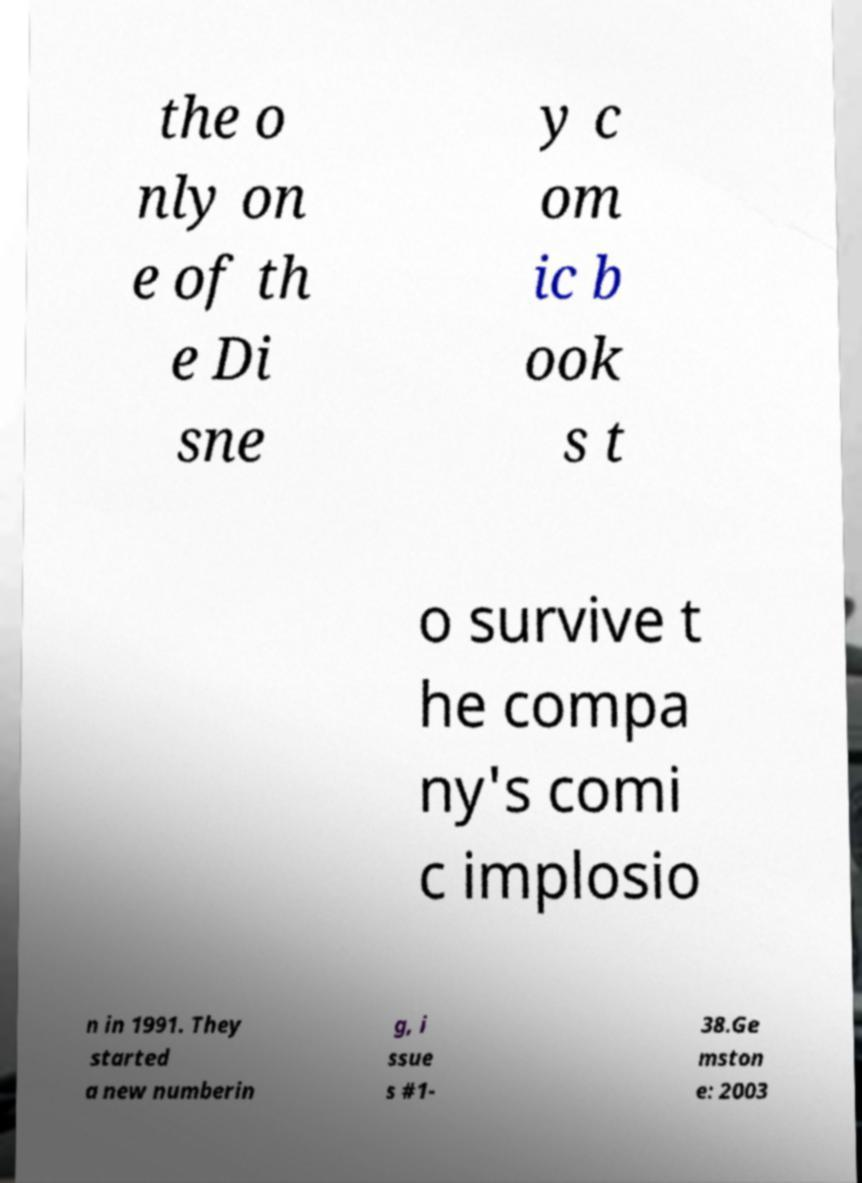What messages or text are displayed in this image? I need them in a readable, typed format. the o nly on e of th e Di sne y c om ic b ook s t o survive t he compa ny's comi c implosio n in 1991. They started a new numberin g, i ssue s #1- 38.Ge mston e: 2003 